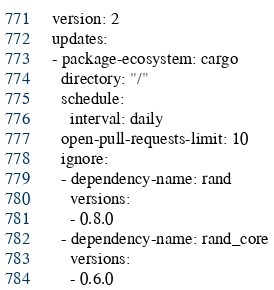<code> <loc_0><loc_0><loc_500><loc_500><_YAML_>version: 2
updates:
- package-ecosystem: cargo
  directory: "/"
  schedule:
    interval: daily
  open-pull-requests-limit: 10
  ignore:
  - dependency-name: rand
    versions:
    - 0.8.0
  - dependency-name: rand_core
    versions:
    - 0.6.0
</code> 